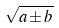Convert formula to latex. <formula><loc_0><loc_0><loc_500><loc_500>\sqrt { a \pm b }</formula> 